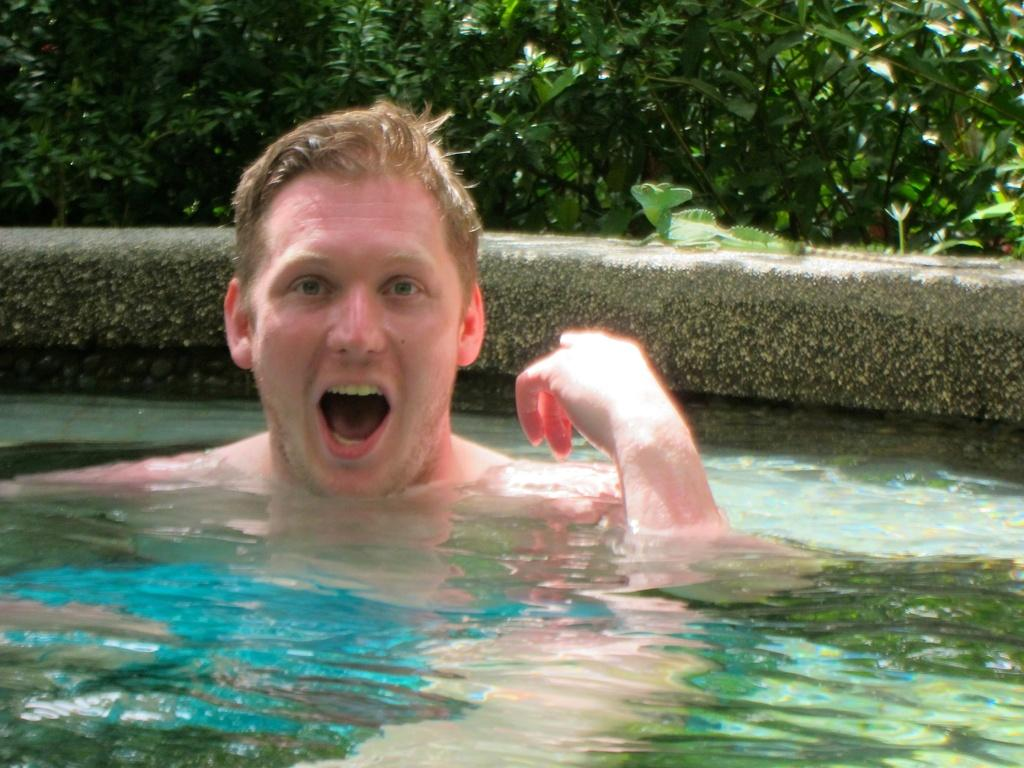What is the person in the image doing? There is a person in the water in the image. What can be seen in the background of the image? There are numerous plants in the background. What is the person's tongue doing in the image? There is no information about the person's tongue in the image, as it only shows the person in the water and plants in the background. 